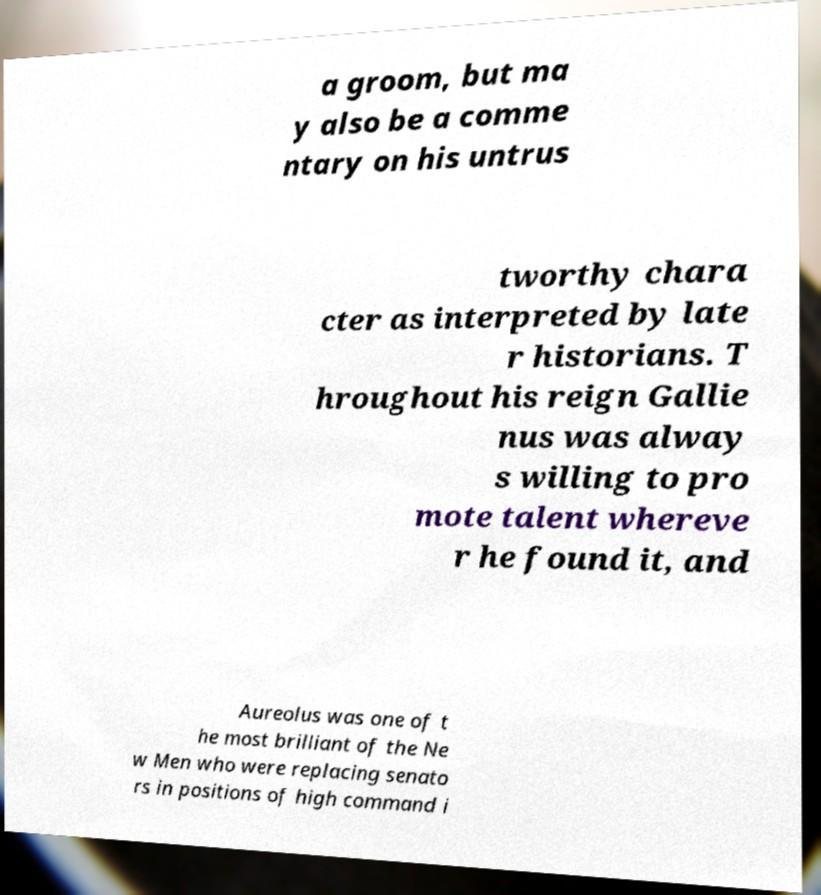Could you assist in decoding the text presented in this image and type it out clearly? a groom, but ma y also be a comme ntary on his untrus tworthy chara cter as interpreted by late r historians. T hroughout his reign Gallie nus was alway s willing to pro mote talent whereve r he found it, and Aureolus was one of t he most brilliant of the Ne w Men who were replacing senato rs in positions of high command i 